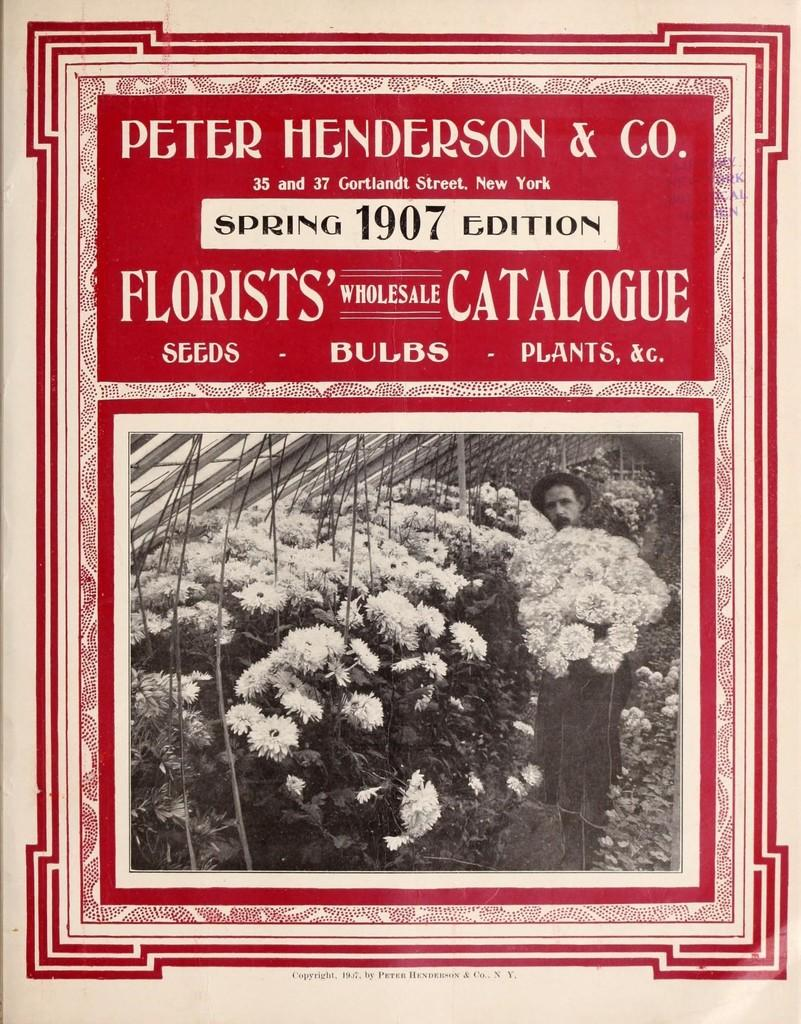What is the color scheme of the image? The image is in black and white. Who is in the image? There is a man in the image. What is the man holding? The man is holding a bouquet of flowers. Where are more flowers located in the image? There are flowers on the left side of the image. What is the man's current debt situation in the image? There is no information about the man's debt situation in the image. What fictional character does the man resemble in the image? The image does not depict any fictional characters, only a man holding a bouquet of flowers. 